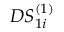<formula> <loc_0><loc_0><loc_500><loc_500>D S _ { 1 i } ^ { ( 1 ) }</formula> 